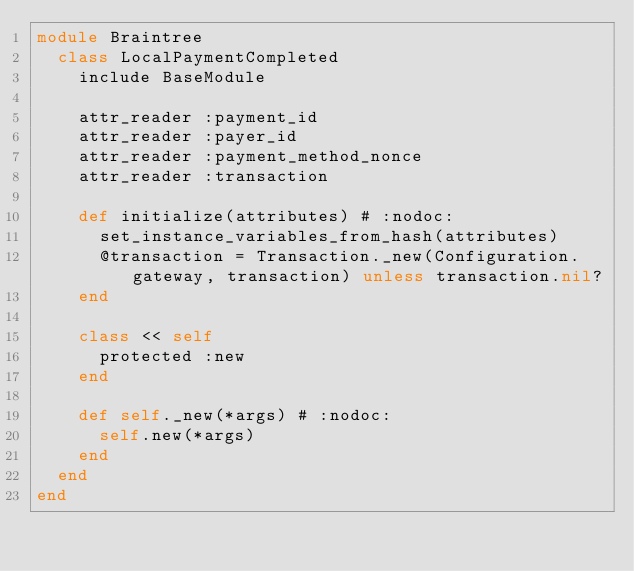Convert code to text. <code><loc_0><loc_0><loc_500><loc_500><_Ruby_>module Braintree
  class LocalPaymentCompleted
    include BaseModule

    attr_reader :payment_id
    attr_reader :payer_id
    attr_reader :payment_method_nonce
    attr_reader :transaction

    def initialize(attributes) # :nodoc:
      set_instance_variables_from_hash(attributes)
      @transaction = Transaction._new(Configuration.gateway, transaction) unless transaction.nil?
    end

    class << self
      protected :new
    end

    def self._new(*args) # :nodoc:
      self.new(*args)
    end
  end
end
</code> 